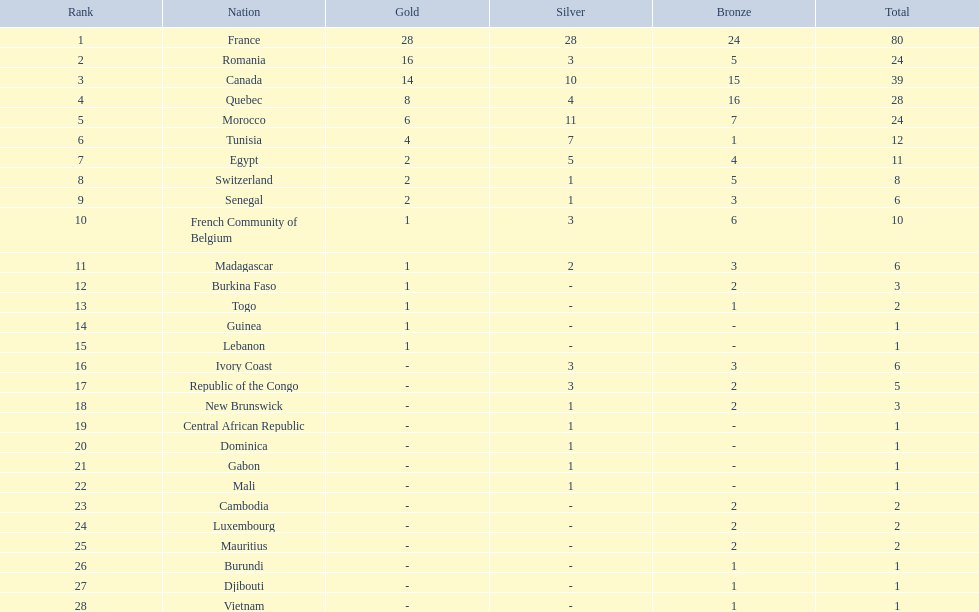How do the silver medals of france and egypt differ from each other? 23. 